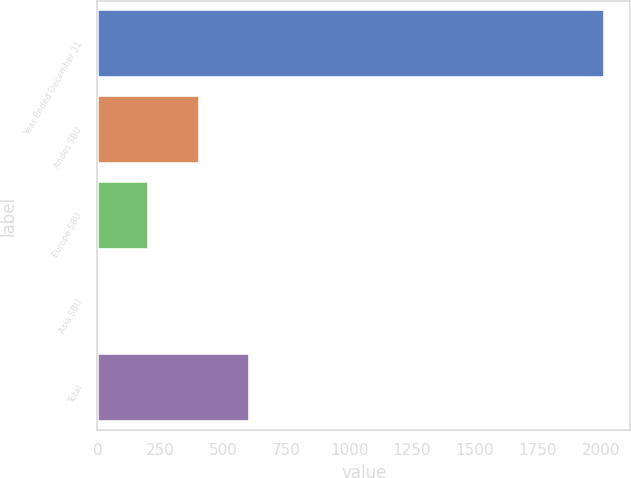<chart> <loc_0><loc_0><loc_500><loc_500><bar_chart><fcel>Year Ended December 31<fcel>Andes SBU<fcel>Europe SBU<fcel>Asia SBU<fcel>Total<nl><fcel>2016<fcel>405.6<fcel>204.3<fcel>3<fcel>606.9<nl></chart> 